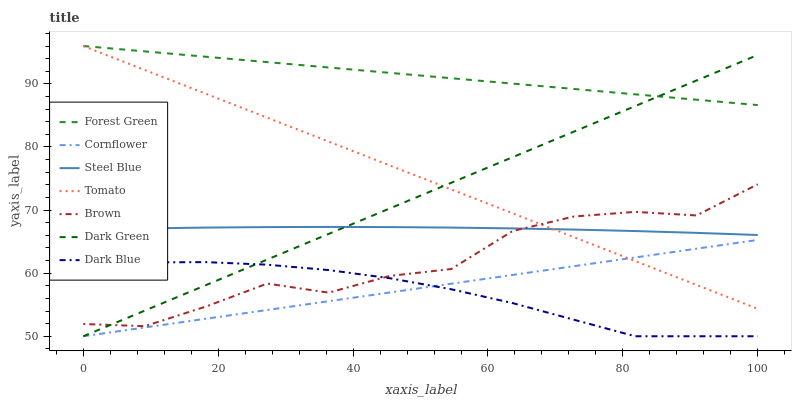Does Cornflower have the minimum area under the curve?
Answer yes or no. No. Does Cornflower have the maximum area under the curve?
Answer yes or no. No. Is Cornflower the smoothest?
Answer yes or no. No. Is Cornflower the roughest?
Answer yes or no. No. Does Brown have the lowest value?
Answer yes or no. No. Does Cornflower have the highest value?
Answer yes or no. No. Is Steel Blue less than Forest Green?
Answer yes or no. Yes. Is Forest Green greater than Brown?
Answer yes or no. Yes. Does Steel Blue intersect Forest Green?
Answer yes or no. No. 